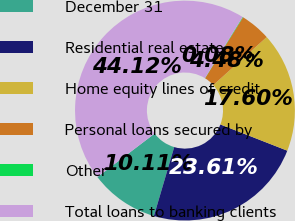Convert chart. <chart><loc_0><loc_0><loc_500><loc_500><pie_chart><fcel>December 31<fcel>Residential real estate<fcel>Home equity lines of credit<fcel>Personal loans secured by<fcel>Other<fcel>Total loans to banking clients<nl><fcel>10.11%<fcel>23.61%<fcel>17.6%<fcel>4.48%<fcel>0.08%<fcel>44.12%<nl></chart> 